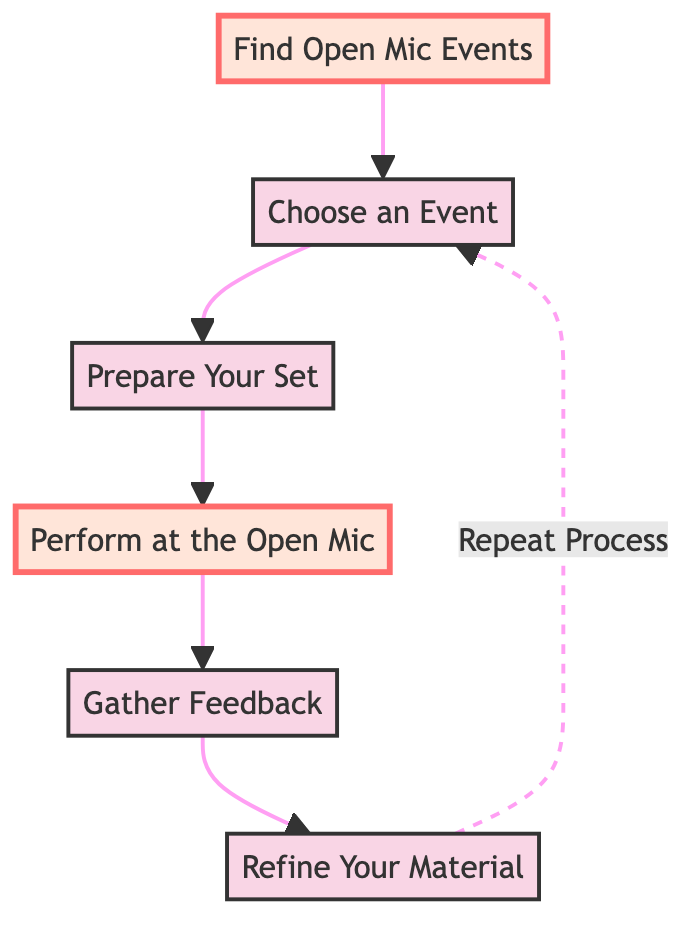What is the first step in the open mic process? The first step, as illustrated in the diagram, is "Find Open Mic Events" which serves as the starting point for aspiring comedians.
Answer: Find Open Mic Events How many total nodes are in the diagram? The diagram contains six distinct nodes that represent the different steps in the open mic process.
Answer: Six Which node comes immediately after choosing an event? The node that follows "Choose an Event" is "Prepare Your Set", indicating the next step in the flow.
Answer: Prepare Your Set What action follows performing at the open mic? After "Perform at the Open Mic", the next action is "Gather Feedback", which is essential for improving future performances.
Answer: Gather Feedback What is the relationship between "Gather Feedback" and "Refine Your Material"? "Gather Feedback" leads directly to "Refine Your Material", showing that feedback is used to improve the set for future performances.
Answer: Leads to Which two nodes highlight the most important actions in the diagram? The highlighted nodes are "Find Open Mic Events" and "Perform at the Open Mic", indicating their significance in the overall process.
Answer: Find Open Mic Events, Perform at the Open Mic What is the last step in the flow before repeating the process? The last action before repeating the process is "Refine Your Material", highlighting the importance of revision.
Answer: Refine Your Material How does the process continue after refining material? After refining material, the flow returns to "Choose an Event", indicating that the cycle of preparation and performance is ongoing.
Answer: Choose an Event 